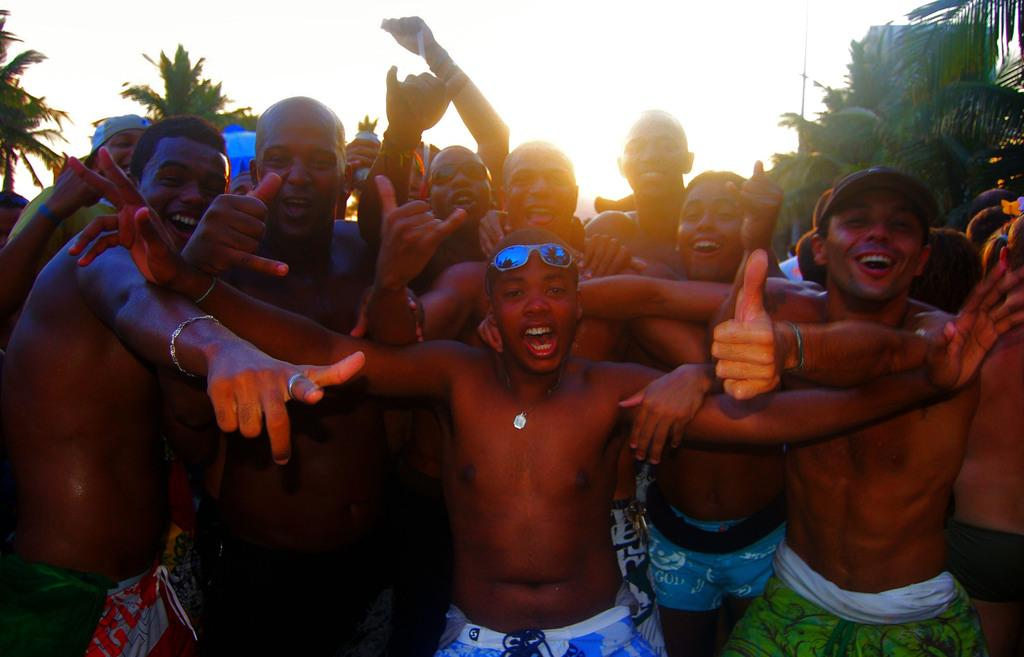Who or what can be seen in the front of the image? There are people in the front of the image. What can be seen in the distance behind the people? There are trees in the background of the image. What else is visible in the background? There is sky visible in the background of the image. What item is near a person in the image? There are goggles near a person in the image. What type of toys are the children playing with in the image? There are no children or toys present in the image. 